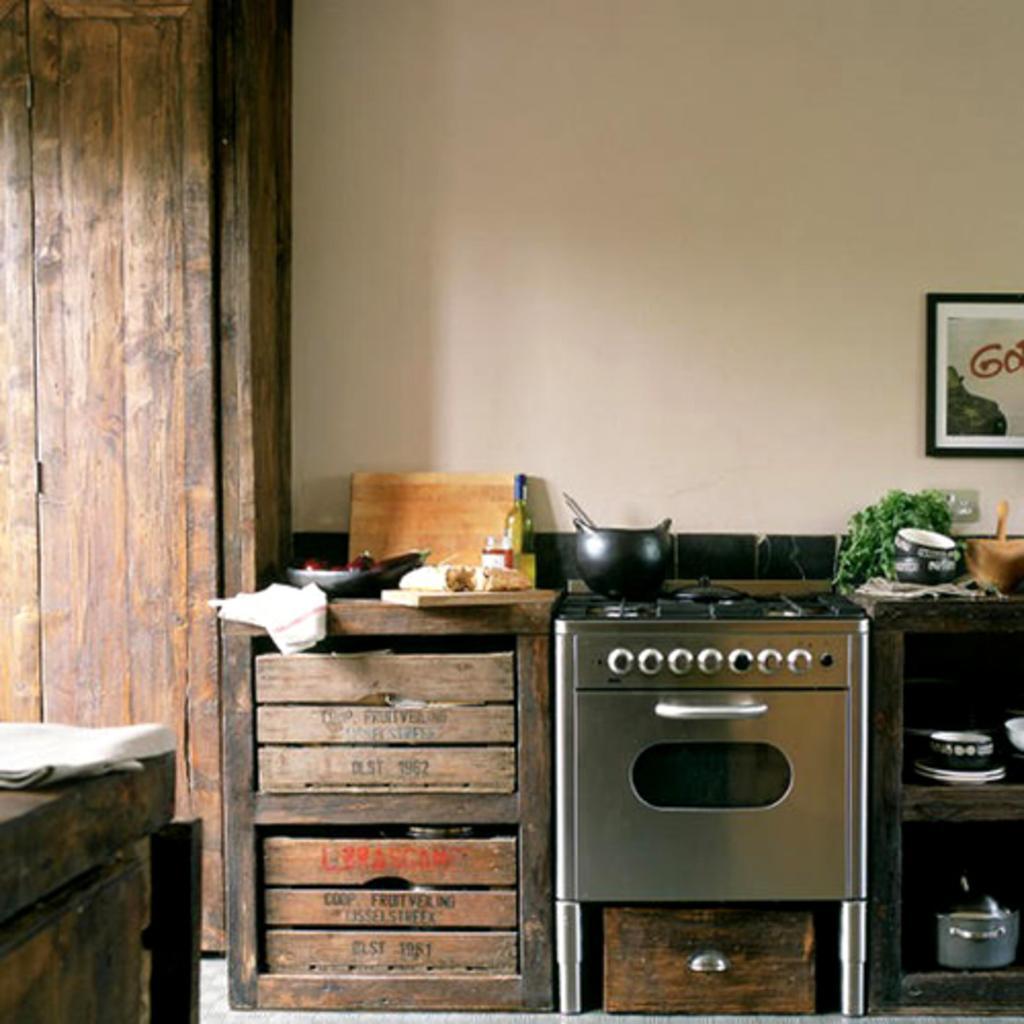Please provide a concise description of this image. The photo is taken inside a kitchen. There is a stove in the middle. On the both side of it there are racks. There are few other cooking stuff on the counter. On the wall there is a painting. The wall is white in color. Beside the counter there is a cupboard. 